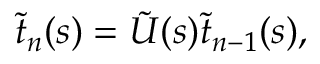<formula> <loc_0><loc_0><loc_500><loc_500>\tilde { t } _ { n } ( s ) = \tilde { U } ( s ) \tilde { t } _ { n - 1 } ( s ) ,</formula> 